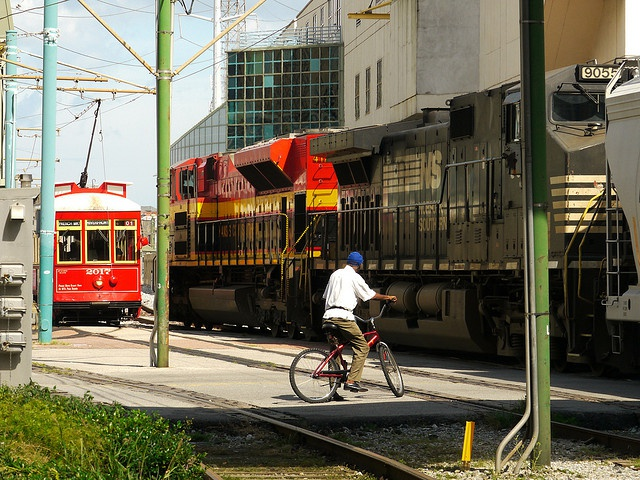Describe the objects in this image and their specific colors. I can see train in tan, black, gray, and maroon tones, train in tan, red, black, ivory, and khaki tones, people in tan, white, black, and gray tones, and bicycle in tan, black, gray, and darkgray tones in this image. 